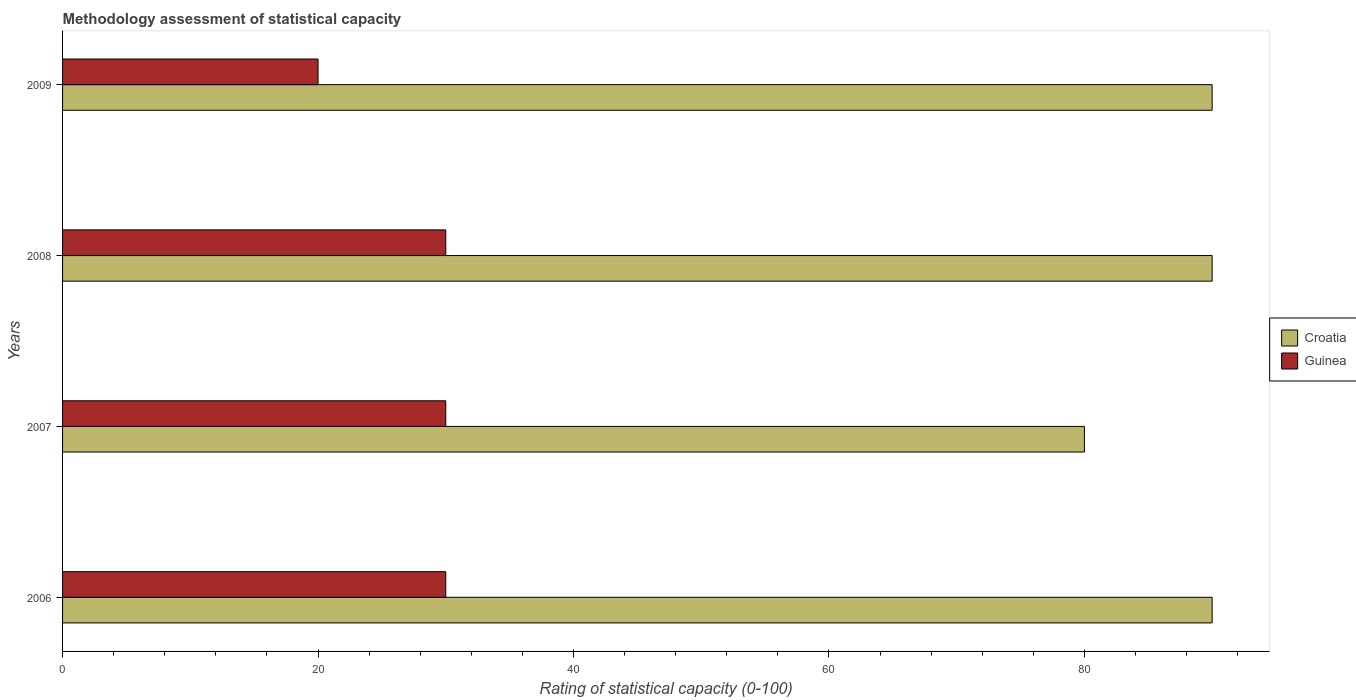How many different coloured bars are there?
Keep it short and to the point. 2. How many groups of bars are there?
Your response must be concise. 4. Are the number of bars on each tick of the Y-axis equal?
Offer a terse response. Yes. What is the label of the 4th group of bars from the top?
Keep it short and to the point. 2006. What is the rating of statistical capacity in Croatia in 2008?
Ensure brevity in your answer.  90. Across all years, what is the maximum rating of statistical capacity in Guinea?
Your response must be concise. 30. Across all years, what is the minimum rating of statistical capacity in Croatia?
Your answer should be very brief. 80. What is the total rating of statistical capacity in Croatia in the graph?
Offer a very short reply. 350. What is the difference between the rating of statistical capacity in Guinea in 2006 and that in 2008?
Make the answer very short. 0. What is the difference between the rating of statistical capacity in Guinea in 2009 and the rating of statistical capacity in Croatia in 2008?
Your answer should be very brief. -70. What is the average rating of statistical capacity in Croatia per year?
Keep it short and to the point. 87.5. In the year 2006, what is the difference between the rating of statistical capacity in Guinea and rating of statistical capacity in Croatia?
Your answer should be very brief. -60. In how many years, is the rating of statistical capacity in Guinea greater than 24 ?
Your answer should be very brief. 3. What is the ratio of the rating of statistical capacity in Guinea in 2007 to that in 2009?
Keep it short and to the point. 1.5. What is the difference between the highest and the second highest rating of statistical capacity in Croatia?
Give a very brief answer. 0. What is the difference between the highest and the lowest rating of statistical capacity in Croatia?
Keep it short and to the point. 10. In how many years, is the rating of statistical capacity in Guinea greater than the average rating of statistical capacity in Guinea taken over all years?
Your answer should be very brief. 3. What does the 1st bar from the top in 2006 represents?
Offer a terse response. Guinea. What does the 2nd bar from the bottom in 2006 represents?
Ensure brevity in your answer.  Guinea. How many bars are there?
Ensure brevity in your answer.  8. How many years are there in the graph?
Provide a succinct answer. 4. What is the difference between two consecutive major ticks on the X-axis?
Your response must be concise. 20. Are the values on the major ticks of X-axis written in scientific E-notation?
Keep it short and to the point. No. Does the graph contain any zero values?
Keep it short and to the point. No. Where does the legend appear in the graph?
Make the answer very short. Center right. How many legend labels are there?
Provide a succinct answer. 2. What is the title of the graph?
Give a very brief answer. Methodology assessment of statistical capacity. What is the label or title of the X-axis?
Ensure brevity in your answer.  Rating of statistical capacity (0-100). What is the Rating of statistical capacity (0-100) in Croatia in 2006?
Your answer should be very brief. 90. What is the Rating of statistical capacity (0-100) of Guinea in 2006?
Your answer should be compact. 30. What is the Rating of statistical capacity (0-100) of Croatia in 2007?
Your answer should be very brief. 80. What is the Rating of statistical capacity (0-100) in Guinea in 2007?
Give a very brief answer. 30. What is the Rating of statistical capacity (0-100) in Guinea in 2008?
Your answer should be compact. 30. Across all years, what is the maximum Rating of statistical capacity (0-100) in Croatia?
Ensure brevity in your answer.  90. Across all years, what is the maximum Rating of statistical capacity (0-100) in Guinea?
Your answer should be very brief. 30. What is the total Rating of statistical capacity (0-100) of Croatia in the graph?
Keep it short and to the point. 350. What is the total Rating of statistical capacity (0-100) of Guinea in the graph?
Your response must be concise. 110. What is the difference between the Rating of statistical capacity (0-100) of Croatia in 2006 and that in 2008?
Your response must be concise. 0. What is the difference between the Rating of statistical capacity (0-100) of Guinea in 2006 and that in 2008?
Give a very brief answer. 0. What is the difference between the Rating of statistical capacity (0-100) in Guinea in 2006 and that in 2009?
Give a very brief answer. 10. What is the difference between the Rating of statistical capacity (0-100) in Croatia in 2007 and that in 2009?
Your response must be concise. -10. What is the difference between the Rating of statistical capacity (0-100) of Guinea in 2007 and that in 2009?
Offer a very short reply. 10. What is the difference between the Rating of statistical capacity (0-100) in Croatia in 2006 and the Rating of statistical capacity (0-100) in Guinea in 2008?
Ensure brevity in your answer.  60. What is the difference between the Rating of statistical capacity (0-100) of Croatia in 2007 and the Rating of statistical capacity (0-100) of Guinea in 2008?
Your answer should be very brief. 50. What is the difference between the Rating of statistical capacity (0-100) in Croatia in 2007 and the Rating of statistical capacity (0-100) in Guinea in 2009?
Your answer should be compact. 60. What is the difference between the Rating of statistical capacity (0-100) of Croatia in 2008 and the Rating of statistical capacity (0-100) of Guinea in 2009?
Keep it short and to the point. 70. What is the average Rating of statistical capacity (0-100) of Croatia per year?
Ensure brevity in your answer.  87.5. In the year 2007, what is the difference between the Rating of statistical capacity (0-100) of Croatia and Rating of statistical capacity (0-100) of Guinea?
Your answer should be compact. 50. In the year 2009, what is the difference between the Rating of statistical capacity (0-100) in Croatia and Rating of statistical capacity (0-100) in Guinea?
Your answer should be compact. 70. What is the ratio of the Rating of statistical capacity (0-100) in Croatia in 2006 to that in 2007?
Provide a succinct answer. 1.12. What is the ratio of the Rating of statistical capacity (0-100) in Guinea in 2006 to that in 2007?
Your answer should be compact. 1. What is the ratio of the Rating of statistical capacity (0-100) of Croatia in 2006 to that in 2009?
Offer a very short reply. 1. What is the ratio of the Rating of statistical capacity (0-100) in Guinea in 2006 to that in 2009?
Provide a short and direct response. 1.5. What is the difference between the highest and the second highest Rating of statistical capacity (0-100) of Guinea?
Your answer should be very brief. 0. 